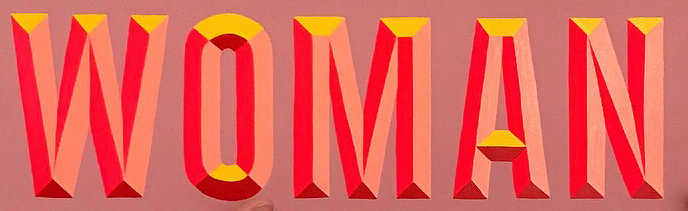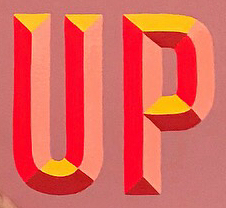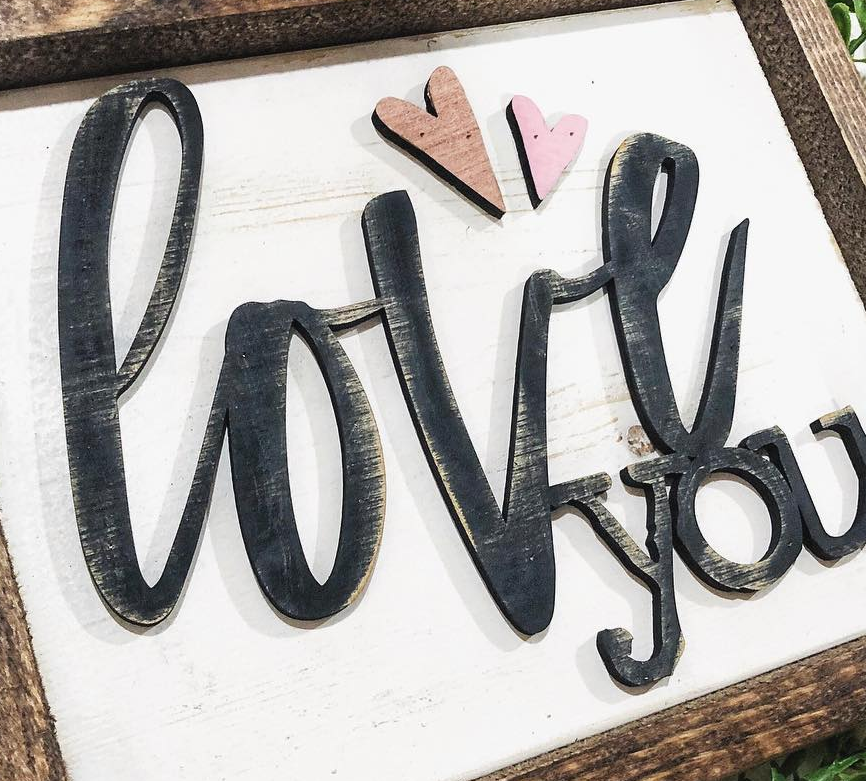Identify the words shown in these images in order, separated by a semicolon. WOMAN; UP; love 